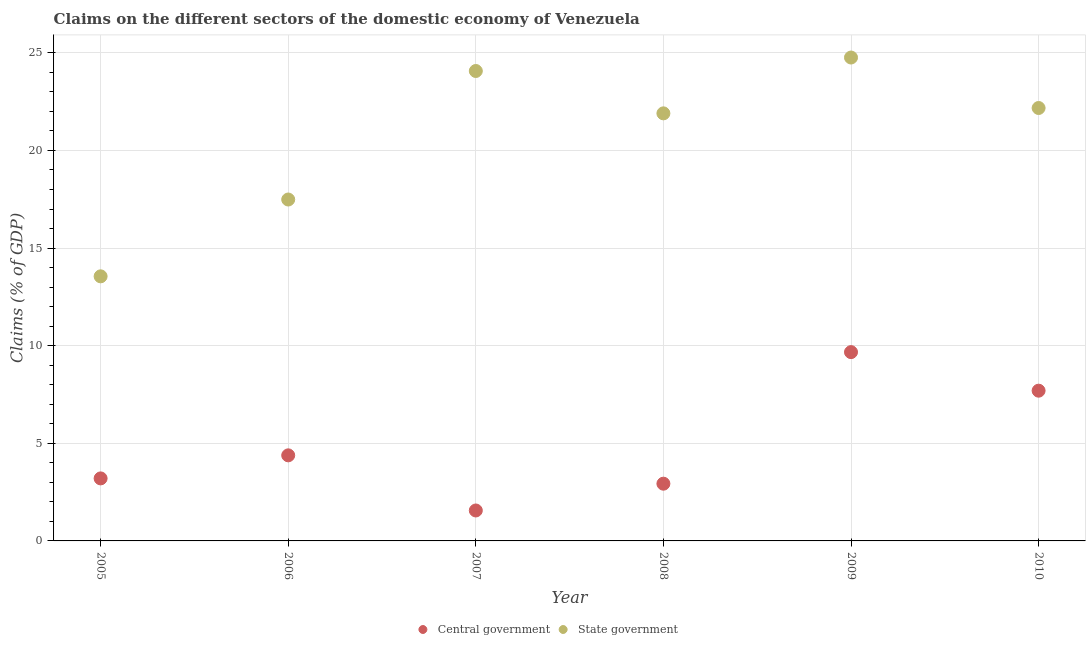What is the claims on central government in 2005?
Give a very brief answer. 3.2. Across all years, what is the maximum claims on central government?
Ensure brevity in your answer.  9.67. Across all years, what is the minimum claims on state government?
Your answer should be very brief. 13.55. In which year was the claims on state government minimum?
Your response must be concise. 2005. What is the total claims on central government in the graph?
Give a very brief answer. 29.44. What is the difference between the claims on state government in 2006 and that in 2009?
Your response must be concise. -7.27. What is the difference between the claims on state government in 2010 and the claims on central government in 2006?
Make the answer very short. 17.79. What is the average claims on central government per year?
Offer a very short reply. 4.91. In the year 2005, what is the difference between the claims on central government and claims on state government?
Offer a very short reply. -10.35. In how many years, is the claims on state government greater than 20 %?
Give a very brief answer. 4. What is the ratio of the claims on central government in 2006 to that in 2010?
Give a very brief answer. 0.57. Is the difference between the claims on central government in 2008 and 2009 greater than the difference between the claims on state government in 2008 and 2009?
Your answer should be compact. No. What is the difference between the highest and the second highest claims on state government?
Offer a very short reply. 0.69. What is the difference between the highest and the lowest claims on central government?
Make the answer very short. 8.11. What is the difference between two consecutive major ticks on the Y-axis?
Offer a very short reply. 5. Are the values on the major ticks of Y-axis written in scientific E-notation?
Make the answer very short. No. Does the graph contain any zero values?
Give a very brief answer. No. Does the graph contain grids?
Your answer should be very brief. Yes. How many legend labels are there?
Your answer should be compact. 2. How are the legend labels stacked?
Your answer should be compact. Horizontal. What is the title of the graph?
Make the answer very short. Claims on the different sectors of the domestic economy of Venezuela. Does "GDP per capita" appear as one of the legend labels in the graph?
Offer a terse response. No. What is the label or title of the Y-axis?
Offer a very short reply. Claims (% of GDP). What is the Claims (% of GDP) of Central government in 2005?
Your answer should be compact. 3.2. What is the Claims (% of GDP) in State government in 2005?
Offer a terse response. 13.55. What is the Claims (% of GDP) in Central government in 2006?
Offer a terse response. 4.38. What is the Claims (% of GDP) in State government in 2006?
Provide a short and direct response. 17.49. What is the Claims (% of GDP) in Central government in 2007?
Your answer should be very brief. 1.56. What is the Claims (% of GDP) of State government in 2007?
Offer a terse response. 24.07. What is the Claims (% of GDP) of Central government in 2008?
Your response must be concise. 2.93. What is the Claims (% of GDP) of State government in 2008?
Offer a very short reply. 21.9. What is the Claims (% of GDP) in Central government in 2009?
Offer a terse response. 9.67. What is the Claims (% of GDP) of State government in 2009?
Offer a terse response. 24.76. What is the Claims (% of GDP) of Central government in 2010?
Provide a short and direct response. 7.7. What is the Claims (% of GDP) of State government in 2010?
Offer a very short reply. 22.17. Across all years, what is the maximum Claims (% of GDP) of Central government?
Provide a short and direct response. 9.67. Across all years, what is the maximum Claims (% of GDP) of State government?
Your answer should be compact. 24.76. Across all years, what is the minimum Claims (% of GDP) in Central government?
Offer a very short reply. 1.56. Across all years, what is the minimum Claims (% of GDP) of State government?
Your answer should be very brief. 13.55. What is the total Claims (% of GDP) in Central government in the graph?
Ensure brevity in your answer.  29.44. What is the total Claims (% of GDP) of State government in the graph?
Your response must be concise. 123.94. What is the difference between the Claims (% of GDP) of Central government in 2005 and that in 2006?
Your response must be concise. -1.18. What is the difference between the Claims (% of GDP) of State government in 2005 and that in 2006?
Provide a succinct answer. -3.93. What is the difference between the Claims (% of GDP) of Central government in 2005 and that in 2007?
Provide a succinct answer. 1.64. What is the difference between the Claims (% of GDP) of State government in 2005 and that in 2007?
Your response must be concise. -10.52. What is the difference between the Claims (% of GDP) in Central government in 2005 and that in 2008?
Offer a very short reply. 0.27. What is the difference between the Claims (% of GDP) of State government in 2005 and that in 2008?
Provide a short and direct response. -8.35. What is the difference between the Claims (% of GDP) in Central government in 2005 and that in 2009?
Make the answer very short. -6.47. What is the difference between the Claims (% of GDP) of State government in 2005 and that in 2009?
Make the answer very short. -11.21. What is the difference between the Claims (% of GDP) of Central government in 2005 and that in 2010?
Your answer should be very brief. -4.49. What is the difference between the Claims (% of GDP) in State government in 2005 and that in 2010?
Keep it short and to the point. -8.62. What is the difference between the Claims (% of GDP) in Central government in 2006 and that in 2007?
Your answer should be compact. 2.82. What is the difference between the Claims (% of GDP) of State government in 2006 and that in 2007?
Keep it short and to the point. -6.58. What is the difference between the Claims (% of GDP) in Central government in 2006 and that in 2008?
Give a very brief answer. 1.45. What is the difference between the Claims (% of GDP) in State government in 2006 and that in 2008?
Offer a terse response. -4.41. What is the difference between the Claims (% of GDP) in Central government in 2006 and that in 2009?
Ensure brevity in your answer.  -5.29. What is the difference between the Claims (% of GDP) of State government in 2006 and that in 2009?
Provide a succinct answer. -7.27. What is the difference between the Claims (% of GDP) in Central government in 2006 and that in 2010?
Offer a terse response. -3.31. What is the difference between the Claims (% of GDP) in State government in 2006 and that in 2010?
Keep it short and to the point. -4.69. What is the difference between the Claims (% of GDP) in Central government in 2007 and that in 2008?
Give a very brief answer. -1.37. What is the difference between the Claims (% of GDP) in State government in 2007 and that in 2008?
Offer a very short reply. 2.17. What is the difference between the Claims (% of GDP) of Central government in 2007 and that in 2009?
Your response must be concise. -8.11. What is the difference between the Claims (% of GDP) in State government in 2007 and that in 2009?
Offer a very short reply. -0.69. What is the difference between the Claims (% of GDP) in Central government in 2007 and that in 2010?
Your answer should be very brief. -6.14. What is the difference between the Claims (% of GDP) in State government in 2007 and that in 2010?
Your answer should be very brief. 1.9. What is the difference between the Claims (% of GDP) in Central government in 2008 and that in 2009?
Provide a short and direct response. -6.74. What is the difference between the Claims (% of GDP) of State government in 2008 and that in 2009?
Your response must be concise. -2.86. What is the difference between the Claims (% of GDP) in Central government in 2008 and that in 2010?
Provide a short and direct response. -4.76. What is the difference between the Claims (% of GDP) in State government in 2008 and that in 2010?
Give a very brief answer. -0.27. What is the difference between the Claims (% of GDP) of Central government in 2009 and that in 2010?
Offer a very short reply. 1.98. What is the difference between the Claims (% of GDP) of State government in 2009 and that in 2010?
Ensure brevity in your answer.  2.59. What is the difference between the Claims (% of GDP) of Central government in 2005 and the Claims (% of GDP) of State government in 2006?
Ensure brevity in your answer.  -14.28. What is the difference between the Claims (% of GDP) in Central government in 2005 and the Claims (% of GDP) in State government in 2007?
Offer a very short reply. -20.87. What is the difference between the Claims (% of GDP) of Central government in 2005 and the Claims (% of GDP) of State government in 2008?
Your answer should be very brief. -18.7. What is the difference between the Claims (% of GDP) of Central government in 2005 and the Claims (% of GDP) of State government in 2009?
Provide a succinct answer. -21.56. What is the difference between the Claims (% of GDP) of Central government in 2005 and the Claims (% of GDP) of State government in 2010?
Make the answer very short. -18.97. What is the difference between the Claims (% of GDP) of Central government in 2006 and the Claims (% of GDP) of State government in 2007?
Give a very brief answer. -19.69. What is the difference between the Claims (% of GDP) in Central government in 2006 and the Claims (% of GDP) in State government in 2008?
Offer a terse response. -17.52. What is the difference between the Claims (% of GDP) of Central government in 2006 and the Claims (% of GDP) of State government in 2009?
Your response must be concise. -20.38. What is the difference between the Claims (% of GDP) in Central government in 2006 and the Claims (% of GDP) in State government in 2010?
Make the answer very short. -17.79. What is the difference between the Claims (% of GDP) of Central government in 2007 and the Claims (% of GDP) of State government in 2008?
Keep it short and to the point. -20.34. What is the difference between the Claims (% of GDP) in Central government in 2007 and the Claims (% of GDP) in State government in 2009?
Give a very brief answer. -23.2. What is the difference between the Claims (% of GDP) in Central government in 2007 and the Claims (% of GDP) in State government in 2010?
Your answer should be compact. -20.61. What is the difference between the Claims (% of GDP) in Central government in 2008 and the Claims (% of GDP) in State government in 2009?
Your answer should be very brief. -21.83. What is the difference between the Claims (% of GDP) in Central government in 2008 and the Claims (% of GDP) in State government in 2010?
Offer a very short reply. -19.24. What is the difference between the Claims (% of GDP) in Central government in 2009 and the Claims (% of GDP) in State government in 2010?
Your response must be concise. -12.5. What is the average Claims (% of GDP) in Central government per year?
Offer a terse response. 4.91. What is the average Claims (% of GDP) in State government per year?
Offer a terse response. 20.66. In the year 2005, what is the difference between the Claims (% of GDP) of Central government and Claims (% of GDP) of State government?
Keep it short and to the point. -10.35. In the year 2006, what is the difference between the Claims (% of GDP) in Central government and Claims (% of GDP) in State government?
Your answer should be very brief. -13.1. In the year 2007, what is the difference between the Claims (% of GDP) of Central government and Claims (% of GDP) of State government?
Make the answer very short. -22.51. In the year 2008, what is the difference between the Claims (% of GDP) in Central government and Claims (% of GDP) in State government?
Offer a terse response. -18.97. In the year 2009, what is the difference between the Claims (% of GDP) in Central government and Claims (% of GDP) in State government?
Your answer should be very brief. -15.09. In the year 2010, what is the difference between the Claims (% of GDP) of Central government and Claims (% of GDP) of State government?
Provide a short and direct response. -14.48. What is the ratio of the Claims (% of GDP) of Central government in 2005 to that in 2006?
Your response must be concise. 0.73. What is the ratio of the Claims (% of GDP) of State government in 2005 to that in 2006?
Provide a succinct answer. 0.78. What is the ratio of the Claims (% of GDP) of Central government in 2005 to that in 2007?
Give a very brief answer. 2.05. What is the ratio of the Claims (% of GDP) of State government in 2005 to that in 2007?
Provide a succinct answer. 0.56. What is the ratio of the Claims (% of GDP) in Central government in 2005 to that in 2008?
Keep it short and to the point. 1.09. What is the ratio of the Claims (% of GDP) in State government in 2005 to that in 2008?
Offer a very short reply. 0.62. What is the ratio of the Claims (% of GDP) in Central government in 2005 to that in 2009?
Ensure brevity in your answer.  0.33. What is the ratio of the Claims (% of GDP) of State government in 2005 to that in 2009?
Your response must be concise. 0.55. What is the ratio of the Claims (% of GDP) of Central government in 2005 to that in 2010?
Your answer should be compact. 0.42. What is the ratio of the Claims (% of GDP) in State government in 2005 to that in 2010?
Offer a terse response. 0.61. What is the ratio of the Claims (% of GDP) of Central government in 2006 to that in 2007?
Your response must be concise. 2.81. What is the ratio of the Claims (% of GDP) of State government in 2006 to that in 2007?
Offer a very short reply. 0.73. What is the ratio of the Claims (% of GDP) in Central government in 2006 to that in 2008?
Provide a succinct answer. 1.5. What is the ratio of the Claims (% of GDP) in State government in 2006 to that in 2008?
Your answer should be compact. 0.8. What is the ratio of the Claims (% of GDP) of Central government in 2006 to that in 2009?
Offer a terse response. 0.45. What is the ratio of the Claims (% of GDP) in State government in 2006 to that in 2009?
Give a very brief answer. 0.71. What is the ratio of the Claims (% of GDP) in Central government in 2006 to that in 2010?
Ensure brevity in your answer.  0.57. What is the ratio of the Claims (% of GDP) of State government in 2006 to that in 2010?
Offer a terse response. 0.79. What is the ratio of the Claims (% of GDP) in Central government in 2007 to that in 2008?
Your response must be concise. 0.53. What is the ratio of the Claims (% of GDP) of State government in 2007 to that in 2008?
Your answer should be very brief. 1.1. What is the ratio of the Claims (% of GDP) in Central government in 2007 to that in 2009?
Your answer should be compact. 0.16. What is the ratio of the Claims (% of GDP) in State government in 2007 to that in 2009?
Make the answer very short. 0.97. What is the ratio of the Claims (% of GDP) of Central government in 2007 to that in 2010?
Your answer should be very brief. 0.2. What is the ratio of the Claims (% of GDP) in State government in 2007 to that in 2010?
Keep it short and to the point. 1.09. What is the ratio of the Claims (% of GDP) of Central government in 2008 to that in 2009?
Make the answer very short. 0.3. What is the ratio of the Claims (% of GDP) of State government in 2008 to that in 2009?
Provide a short and direct response. 0.88. What is the ratio of the Claims (% of GDP) in Central government in 2008 to that in 2010?
Offer a very short reply. 0.38. What is the ratio of the Claims (% of GDP) in State government in 2008 to that in 2010?
Ensure brevity in your answer.  0.99. What is the ratio of the Claims (% of GDP) in Central government in 2009 to that in 2010?
Ensure brevity in your answer.  1.26. What is the ratio of the Claims (% of GDP) in State government in 2009 to that in 2010?
Ensure brevity in your answer.  1.12. What is the difference between the highest and the second highest Claims (% of GDP) in Central government?
Make the answer very short. 1.98. What is the difference between the highest and the second highest Claims (% of GDP) of State government?
Your response must be concise. 0.69. What is the difference between the highest and the lowest Claims (% of GDP) of Central government?
Keep it short and to the point. 8.11. What is the difference between the highest and the lowest Claims (% of GDP) in State government?
Give a very brief answer. 11.21. 